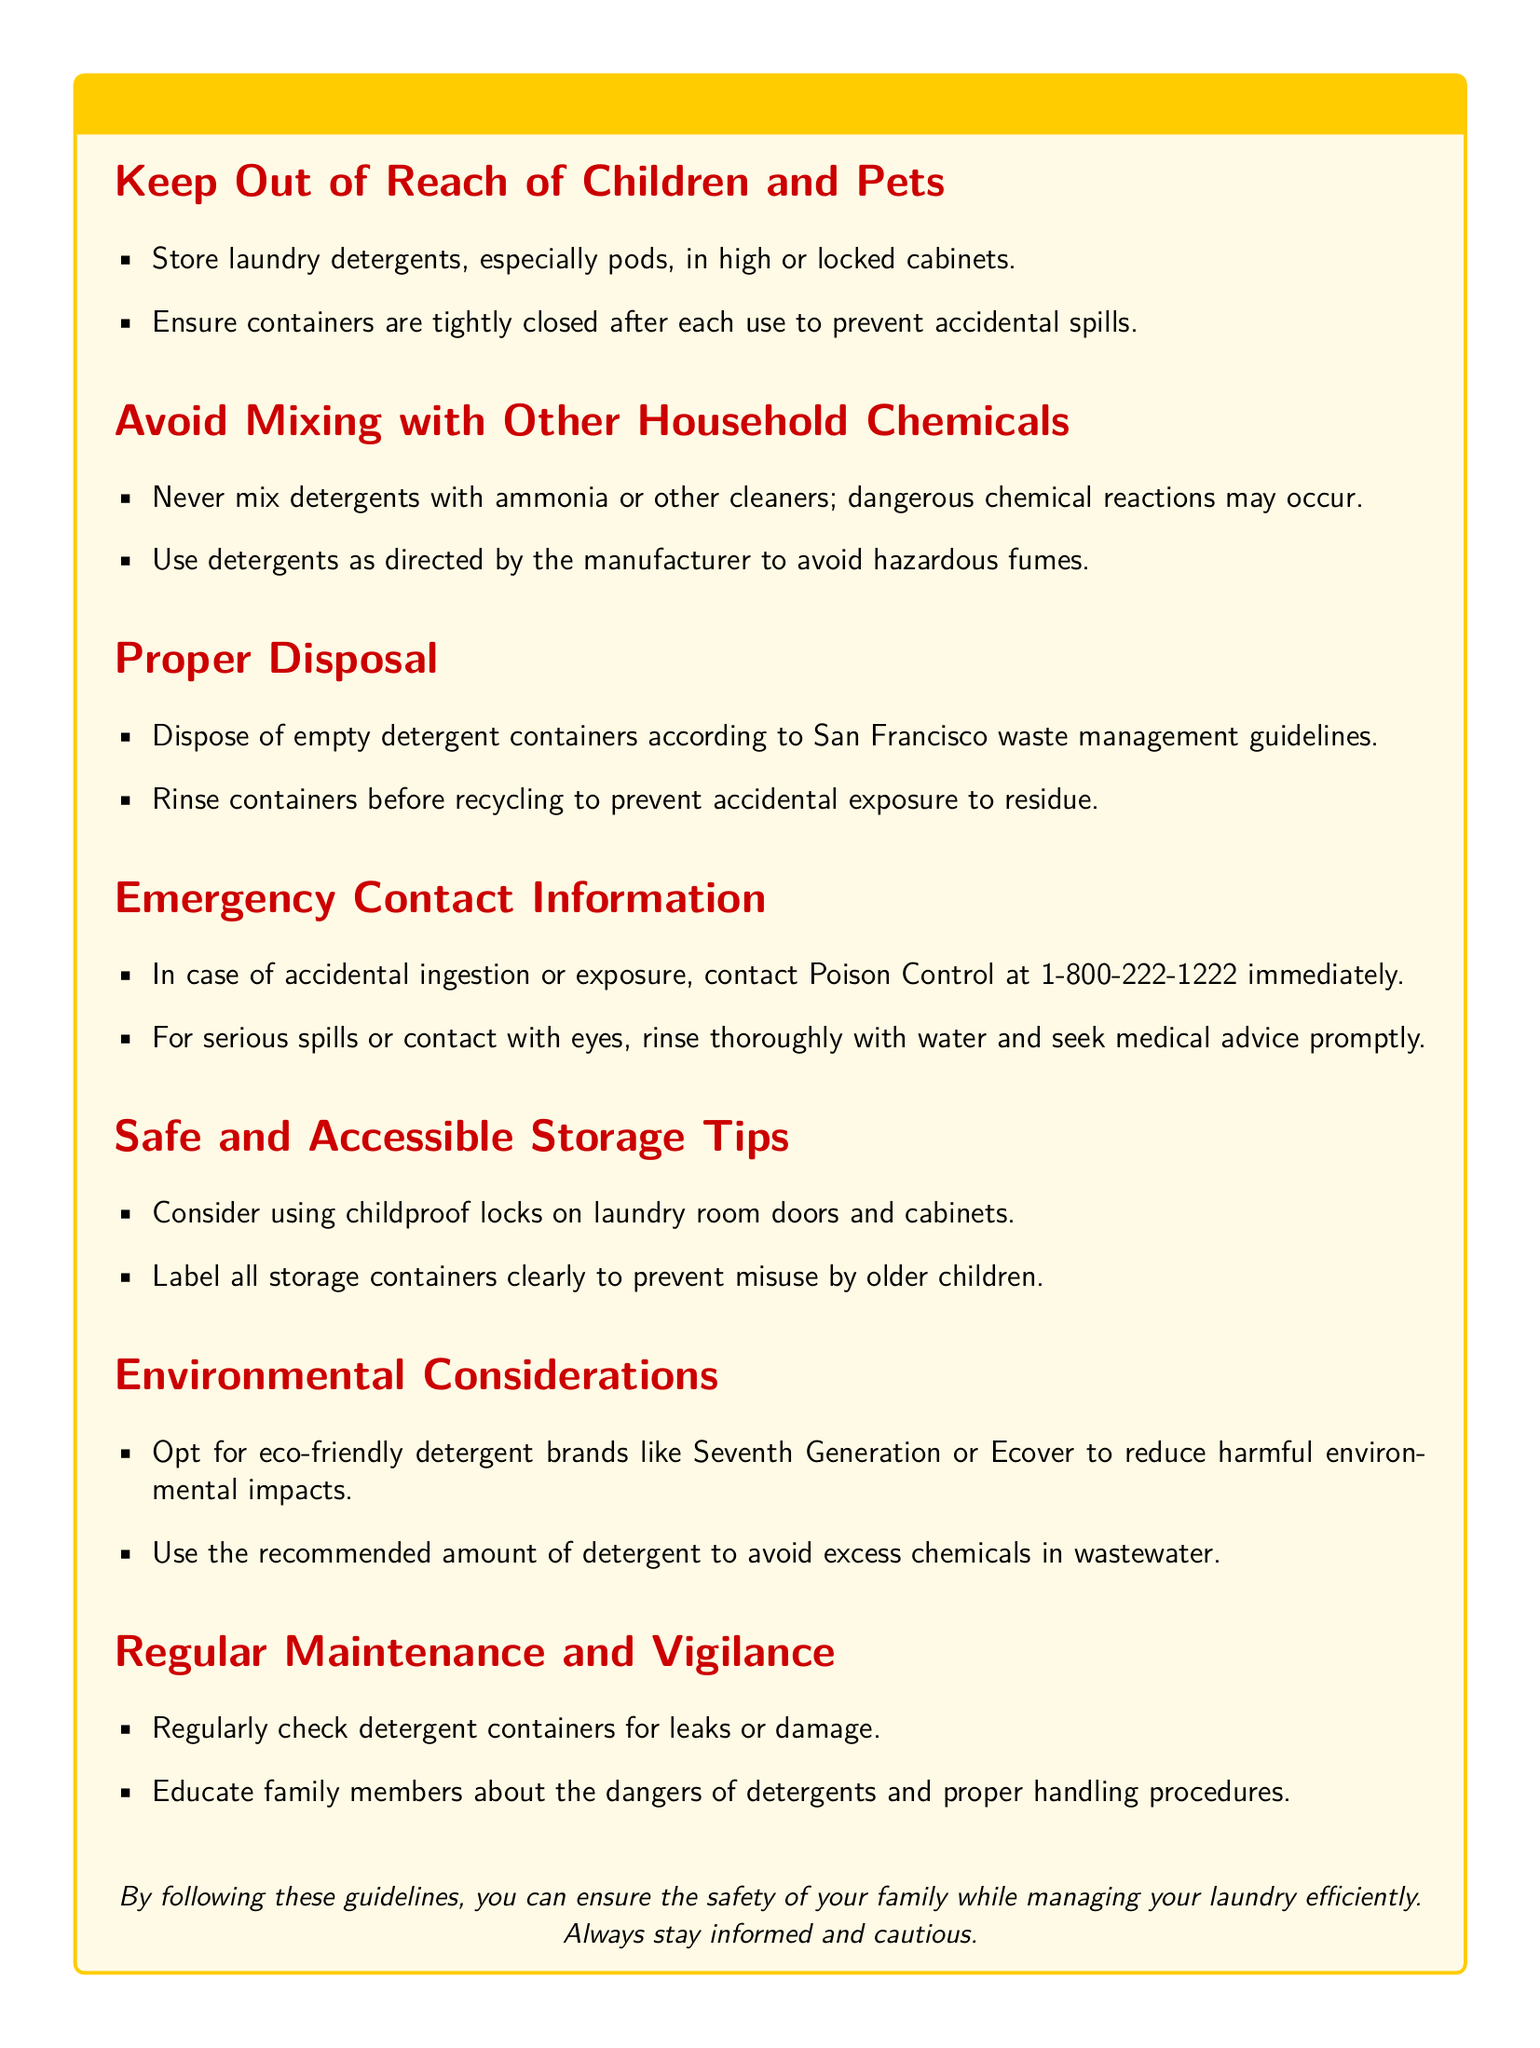What is the emergency contact number for Poison Control? The document states that in case of accidental ingestion or exposure, you should contact Poison Control at 1-800-222-1222 immediately.
Answer: 1-800-222-1222 Where should laundry detergents be stored? The warning label indicates that laundry detergents, especially pods, should be stored in high or locked cabinets.
Answer: High or locked cabinets What should you do with empty detergent containers? The document advises disposing of empty detergent containers according to San Francisco waste management guidelines.
Answer: Dispose according to guidelines Which detergent brands are recommended for environmental considerations? The document suggests opting for eco-friendly detergent brands like Seventh Generation or Ecover.
Answer: Seventh Generation or Ecover What should you never mix with laundry detergents? The warning specifies that you should never mix detergents with ammonia or other cleaners to avoid dangerous chemical reactions.
Answer: Ammonia or other cleaners Why is it important to label storage containers? The document highlights that labeling all storage containers clearly helps prevent misuse by older children.
Answer: To prevent misuse What is one tip for regular maintenance of detergent containers? The warning label states you should regularly check detergent containers for leaks or damage.
Answer: Check for leaks or damage What is recommended for childproofing the storage areas? The document mentions that you should consider using childproof locks on laundry room doors and cabinets.
Answer: Childproof locks What should you do if there is contact with eyes? The document instructs you to rinse thoroughly with water and seek medical advice promptly.
Answer: Rinse thoroughly and seek medical advice 